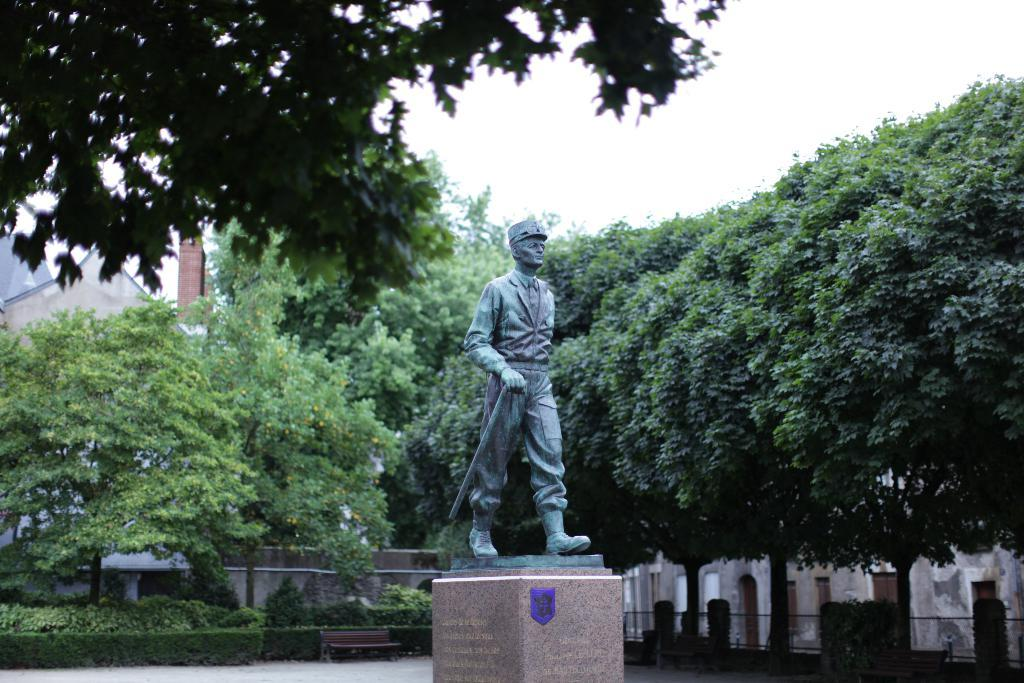What is the main subject in the foreground of the image? There is a statue of a man in the foreground of the image. What type of vegetation can be seen on the right side of the image? There are trees on the right side of the image. Can you describe the design of the ghost in the image? There is no ghost present in the image. 